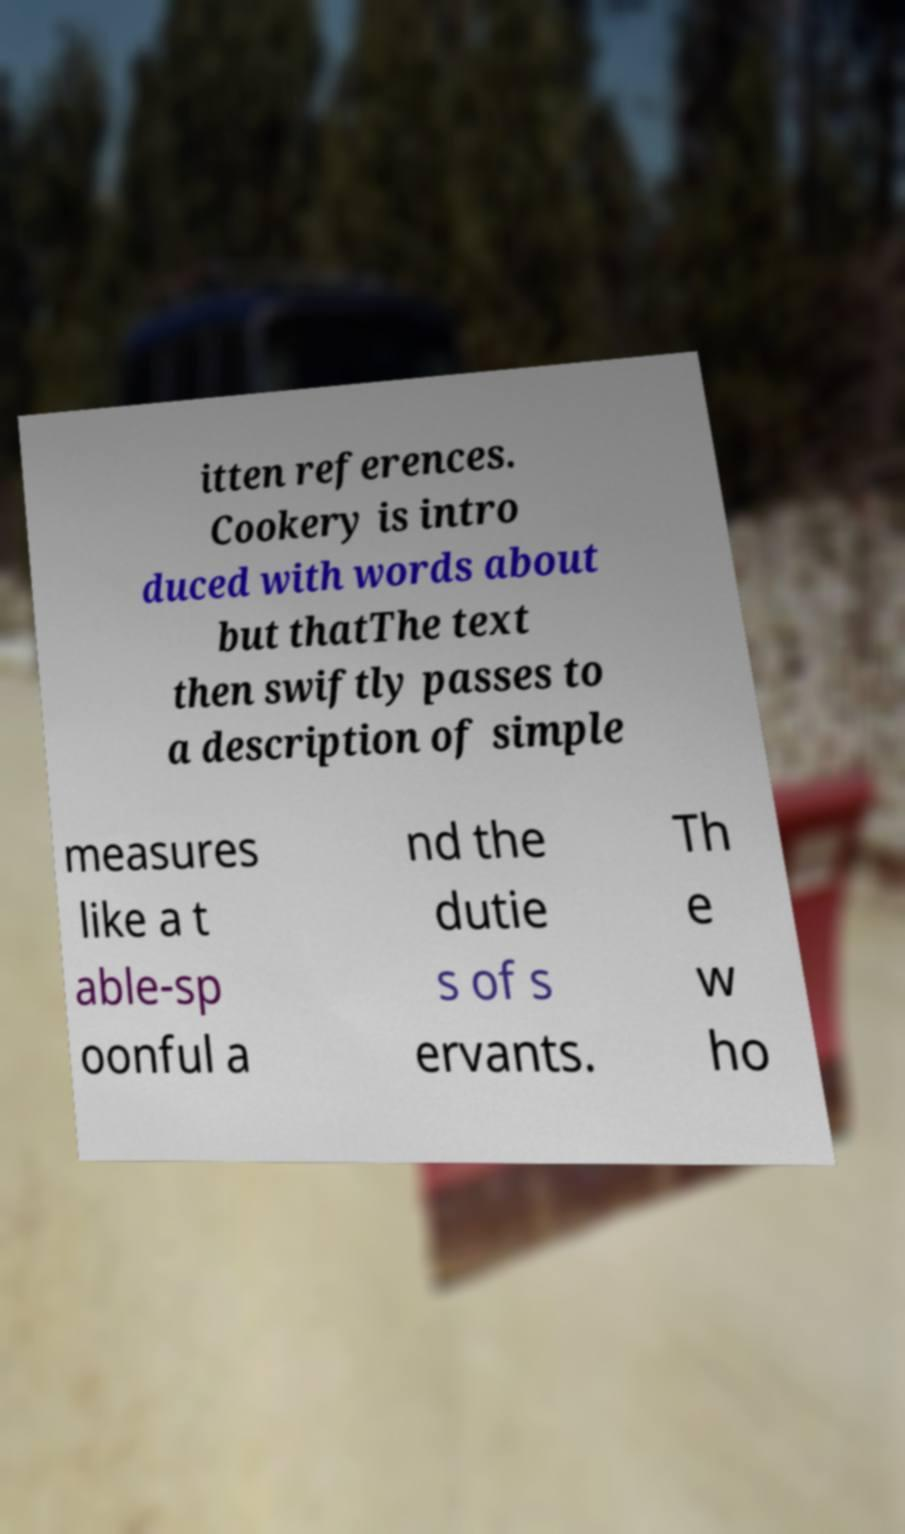Can you read and provide the text displayed in the image?This photo seems to have some interesting text. Can you extract and type it out for me? itten references. Cookery is intro duced with words about but thatThe text then swiftly passes to a description of simple measures like a t able-sp oonful a nd the dutie s of s ervants. Th e w ho 